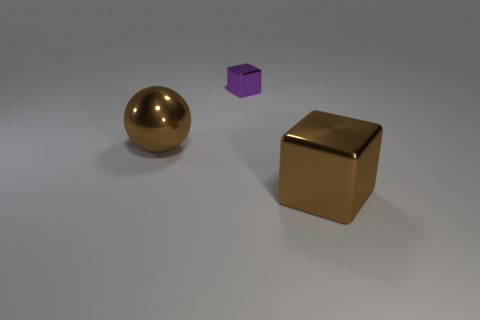Add 1 brown objects. How many objects exist? 4 Subtract all blocks. How many objects are left? 1 Subtract all gray blocks. Subtract all red cylinders. How many blocks are left? 2 Subtract all cyan blocks. How many cyan spheres are left? 0 Subtract all small red rubber cubes. Subtract all large objects. How many objects are left? 1 Add 2 large brown balls. How many large brown balls are left? 3 Add 3 big shiny things. How many big shiny things exist? 5 Subtract all brown blocks. How many blocks are left? 1 Subtract 1 brown blocks. How many objects are left? 2 